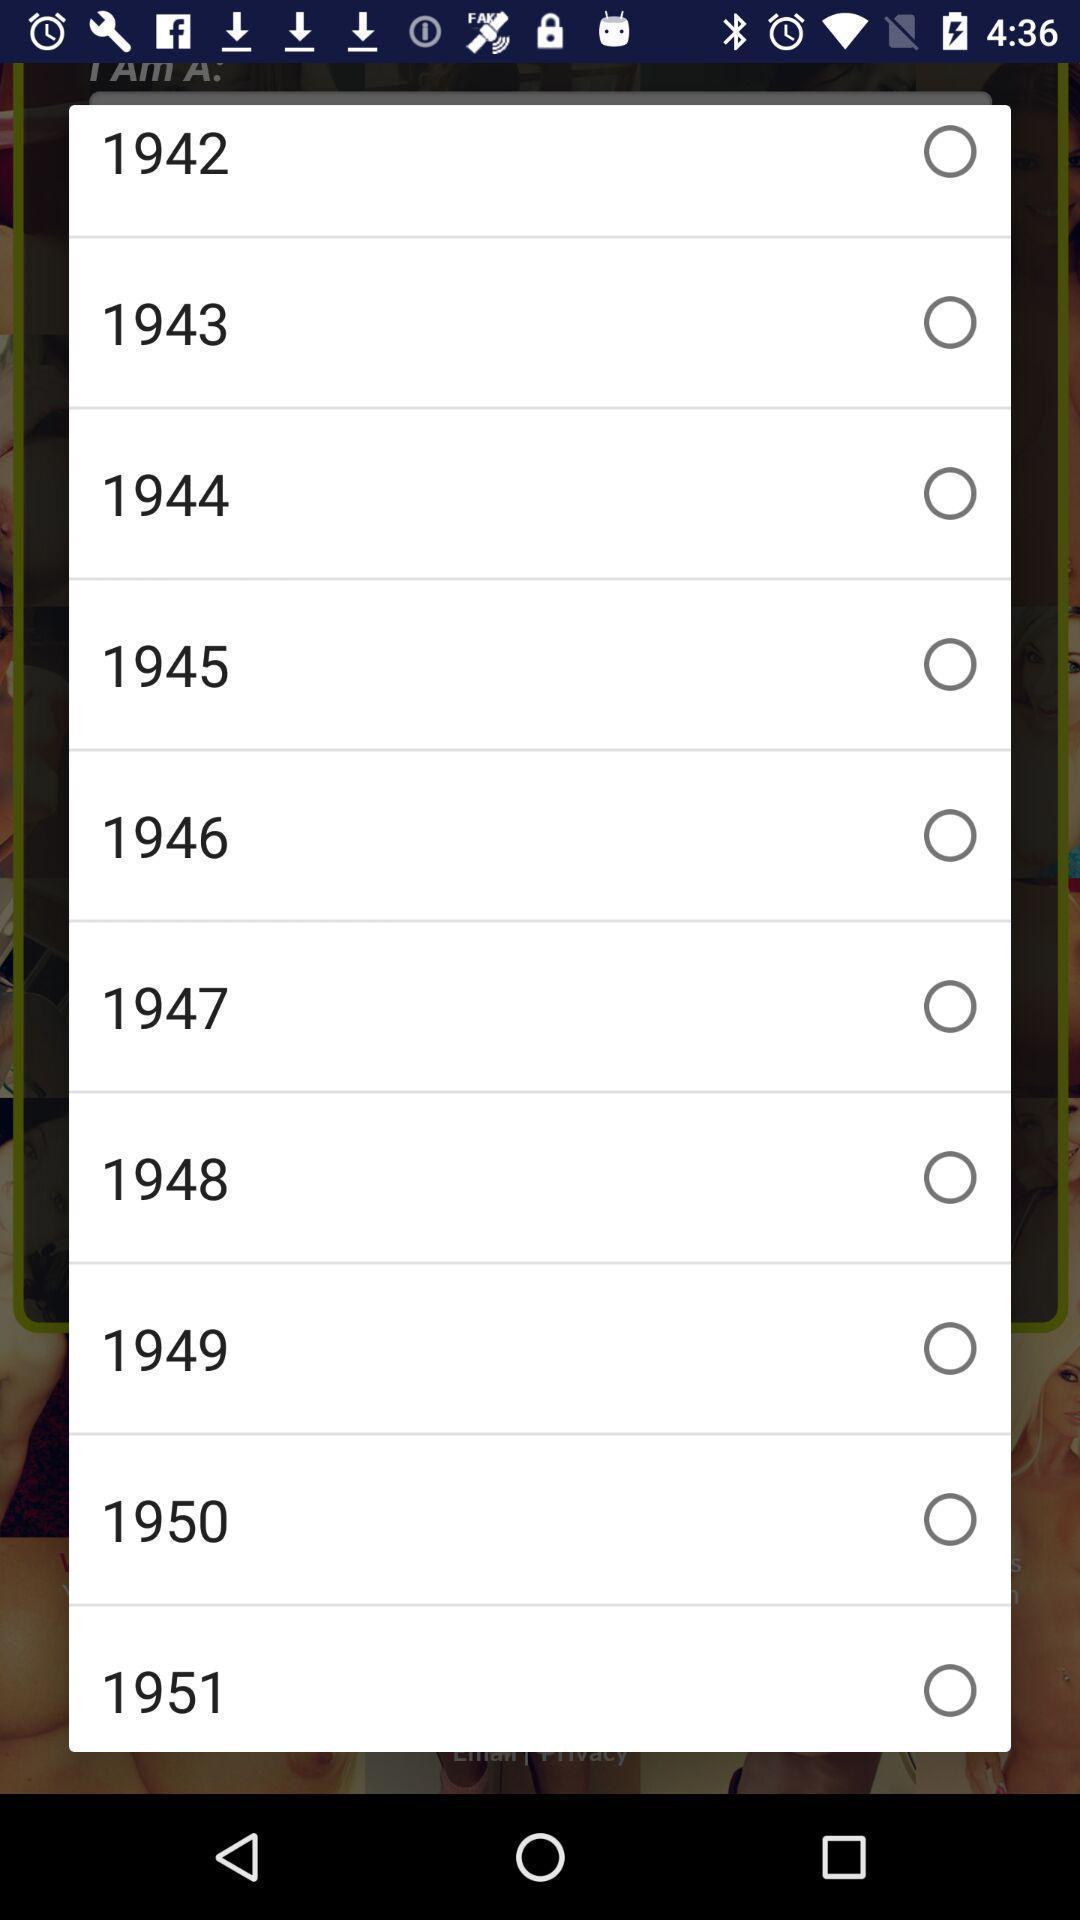Tell me what you see in this picture. Popup displaying years to select. 